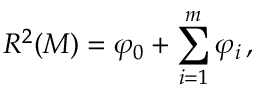<formula> <loc_0><loc_0><loc_500><loc_500>R ^ { 2 } ( M ) = \varphi _ { 0 } + \sum _ { i = 1 } ^ { m } \varphi _ { i } \, ,</formula> 